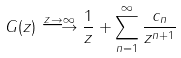<formula> <loc_0><loc_0><loc_500><loc_500>G ( z ) \stackrel { z \rightarrow \infty } { \longrightarrow } \frac { 1 } { z } + \sum _ { n = 1 } ^ { \infty } \frac { c _ { n } } { z ^ { n + 1 } }</formula> 